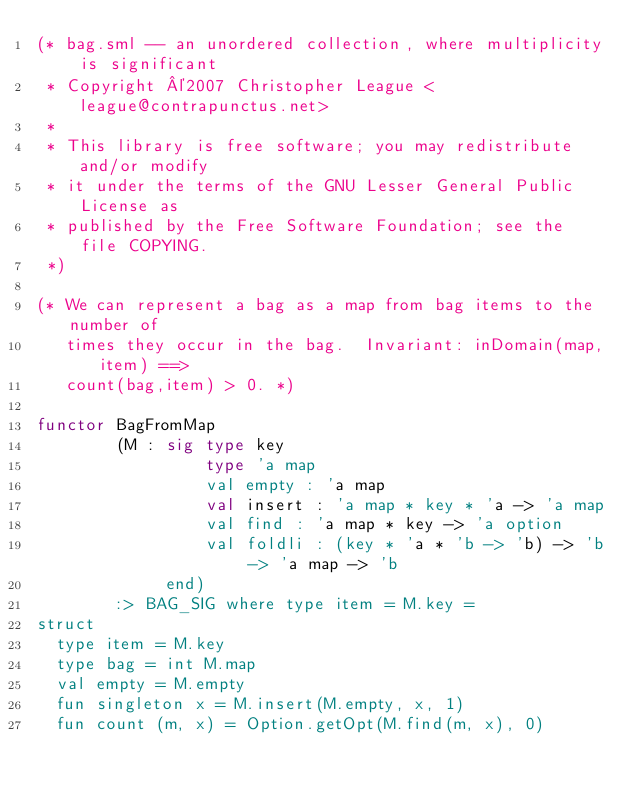Convert code to text. <code><loc_0><loc_0><loc_500><loc_500><_SML_>(* bag.sml -- an unordered collection, where multiplicity is significant
 * Copyright ©2007 Christopher League <league@contrapunctus.net>
 * 
 * This library is free software; you may redistribute and/or modify
 * it under the terms of the GNU Lesser General Public License as
 * published by the Free Software Foundation; see the file COPYING. 
 *)

(* We can represent a bag as a map from bag items to the number of
   times they occur in the bag.  Invariant: inDomain(map,item) ==>
   count(bag,item) > 0. *)

functor BagFromMap 
        (M : sig type key
                 type 'a map
                 val empty : 'a map
                 val insert : 'a map * key * 'a -> 'a map
                 val find : 'a map * key -> 'a option
                 val foldli : (key * 'a * 'b -> 'b) -> 'b -> 'a map -> 'b
             end)
        :> BAG_SIG where type item = M.key =
struct
  type item = M.key
  type bag = int M.map
  val empty = M.empty
  fun singleton x = M.insert(M.empty, x, 1)
  fun count (m, x) = Option.getOpt(M.find(m, x), 0)</code> 